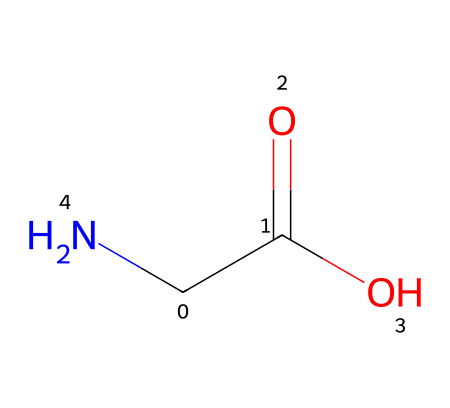What is the molecular formula of this chemical? The SMILES representation indicates three types of atoms: one carbon, two oxygens, and one nitrogen. The molecular formula can be deduced by counting these atoms directly from the representation.
Answer: C2H5NO2 How many total atoms are present in this chemical? By analyzing the molecular formula derived from the SMILES, C2H5NO2 includes a total of five atoms (2 carbon, 5 hydrogen, 1 nitrogen, and 2 oxygen). Adding these gives us the total.
Answer: 5 Is this chemical acidic or basic? The presence of a carboxylic acid group (-COOH) in the structure suggests that the chemical has acidic properties. Thus, it can be considered primarily acidic.
Answer: acidic What functional group is present in this chemical? The presence of the -COOH group in this chemical indicates that it has a carboxylic acid functional group. This can be identified by the -C(=O)O portion of the structure.
Answer: carboxylic acid Does this chemical pose any toxicity concerns for floral arrangements? The chemical represented is a non-toxic stem sealant, and since it is derived from a carboxylic acid, it is usually safe for cut flowers and should not pose toxicity issues.
Answer: non-toxic What state of matter is this chemical expected to be at room temperature? Given that it contains a carboxylic acid group, this chemical is likely to be a liquid or semi-solid at room temperature, as many small carboxylic acids are in such a state.
Answer: liquid 